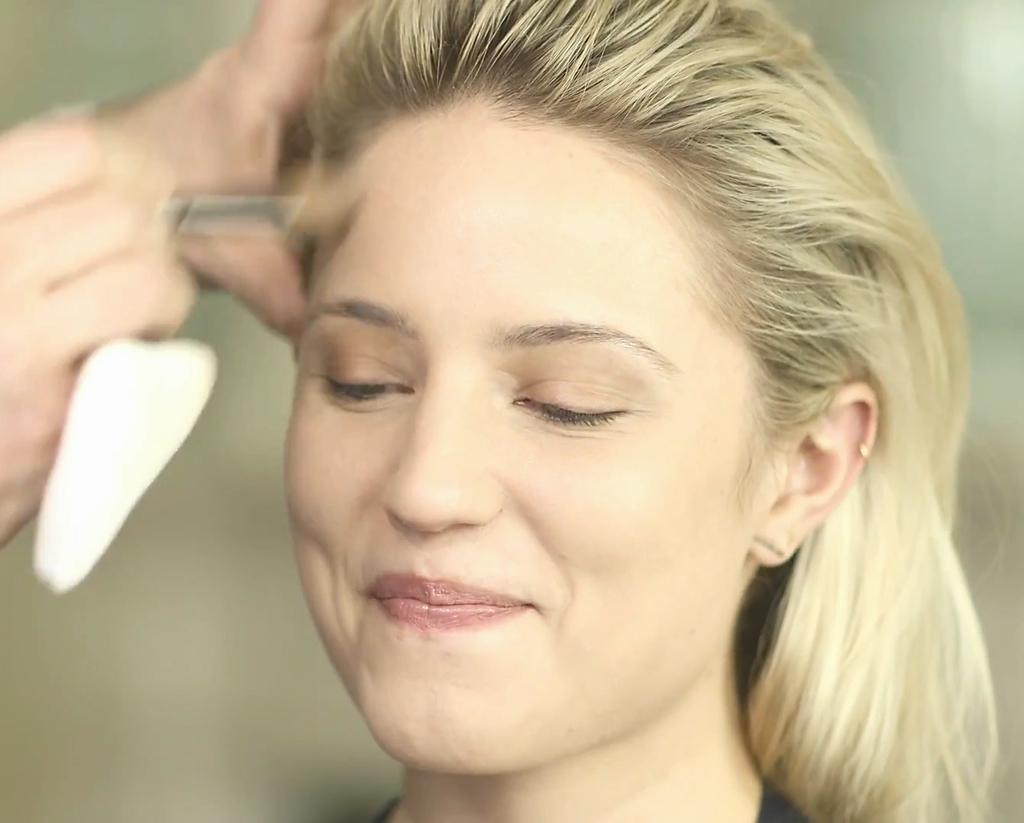Please provide a concise description of this image. In this image we can see a woman is smiling. Here we can see a person's hand holding something which is blurred. The background of the image is blurred and plain. 